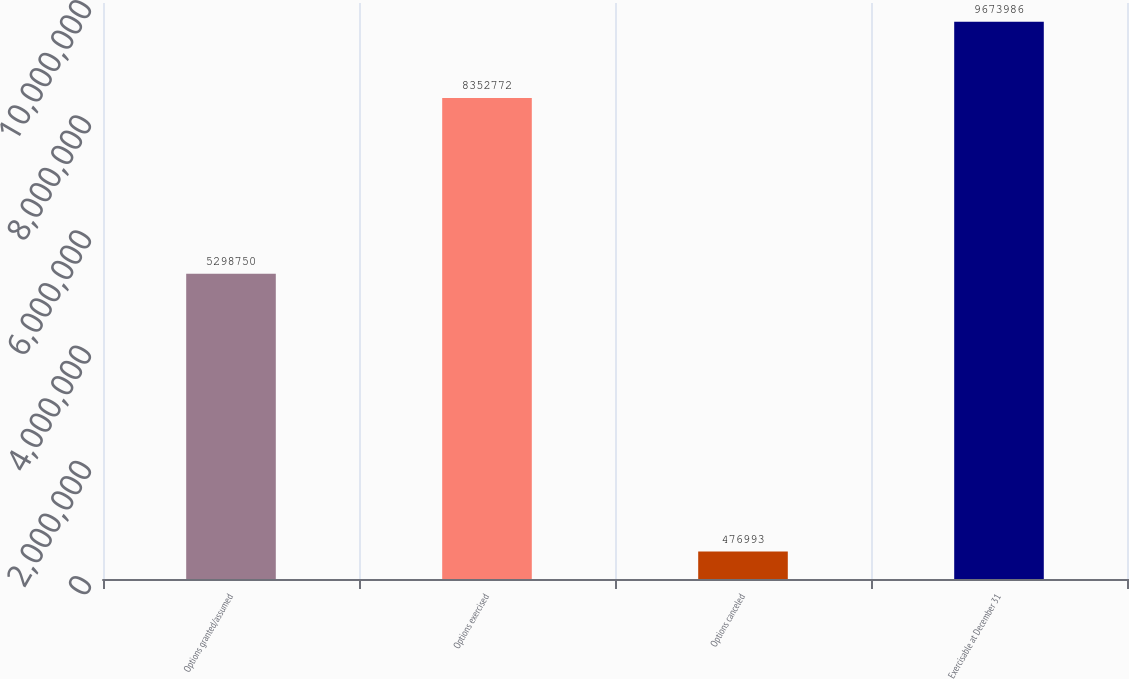Convert chart. <chart><loc_0><loc_0><loc_500><loc_500><bar_chart><fcel>Options granted/assumed<fcel>Options exercised<fcel>Options canceled<fcel>Exercisable at December 31<nl><fcel>5.29875e+06<fcel>8.35277e+06<fcel>476993<fcel>9.67399e+06<nl></chart> 